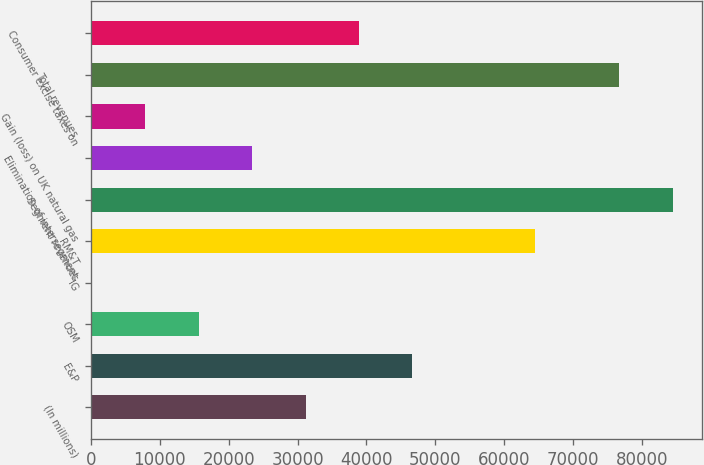<chart> <loc_0><loc_0><loc_500><loc_500><bar_chart><fcel>(In millions)<fcel>E&P<fcel>OSM<fcel>IG<fcel>RM&T<fcel>Segment revenues<fcel>Elimination of intersegment<fcel>Gain (loss) on UK natural gas<fcel>Total revenues<fcel>Consumer excise taxes on<nl><fcel>31153<fcel>46683<fcel>15623<fcel>93<fcel>64481<fcel>84519<fcel>23388<fcel>7858<fcel>76754<fcel>38918<nl></chart> 